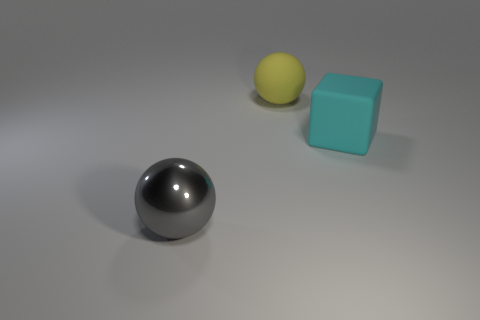Add 2 rubber things. How many objects exist? 5 Subtract all balls. How many objects are left? 1 Subtract all large metallic things. Subtract all tiny red cylinders. How many objects are left? 2 Add 1 big metal spheres. How many big metal spheres are left? 2 Add 3 large yellow metallic cubes. How many large yellow metallic cubes exist? 3 Subtract 0 red blocks. How many objects are left? 3 